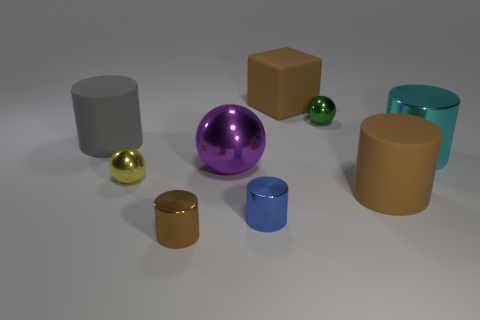Subtract all purple metal spheres. How many spheres are left? 2 Subtract all red cubes. How many brown cylinders are left? 2 Subtract 1 balls. How many balls are left? 2 Subtract all gray cylinders. How many cylinders are left? 4 Add 1 cyan cylinders. How many objects exist? 10 Add 6 blue metal cylinders. How many blue metal cylinders exist? 7 Subtract 1 brown cylinders. How many objects are left? 8 Subtract all spheres. How many objects are left? 6 Subtract all yellow spheres. Subtract all blue cylinders. How many spheres are left? 2 Subtract all brown shiny cylinders. Subtract all blue cylinders. How many objects are left? 7 